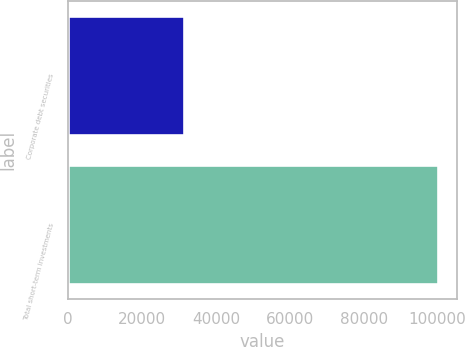<chart> <loc_0><loc_0><loc_500><loc_500><bar_chart><fcel>Corporate debt securities<fcel>Total short-term investments<nl><fcel>31313<fcel>100170<nl></chart> 